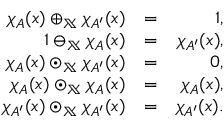<formula> <loc_0><loc_0><loc_500><loc_500>\begin{array} { r l r } { \chi _ { A } ( x ) \oplus _ { \mathbb { X } } \chi _ { A ^ { \prime } } ( x ) } & { = } & { 1 , } \\ { 1 \ominus _ { \mathbb { X } } \chi _ { A } ( x ) } & { = } & { \chi _ { A ^ { \prime } } ( x ) , } \\ { \chi _ { A } ( x ) \odot _ { \mathbb { X } } \chi _ { A ^ { \prime } } ( x ) } & { = } & { 0 , } \\ { \chi _ { A } ( x ) \odot _ { \mathbb { X } } \chi _ { A } ( x ) } & { = } & { \chi _ { A } ( x ) , } \\ { \chi _ { A ^ { \prime } } ( x ) \odot _ { \mathbb { X } } \chi _ { A ^ { \prime } } ( x ) } & { = } & { \chi _ { A ^ { \prime } } ( x ) . } \end{array}</formula> 